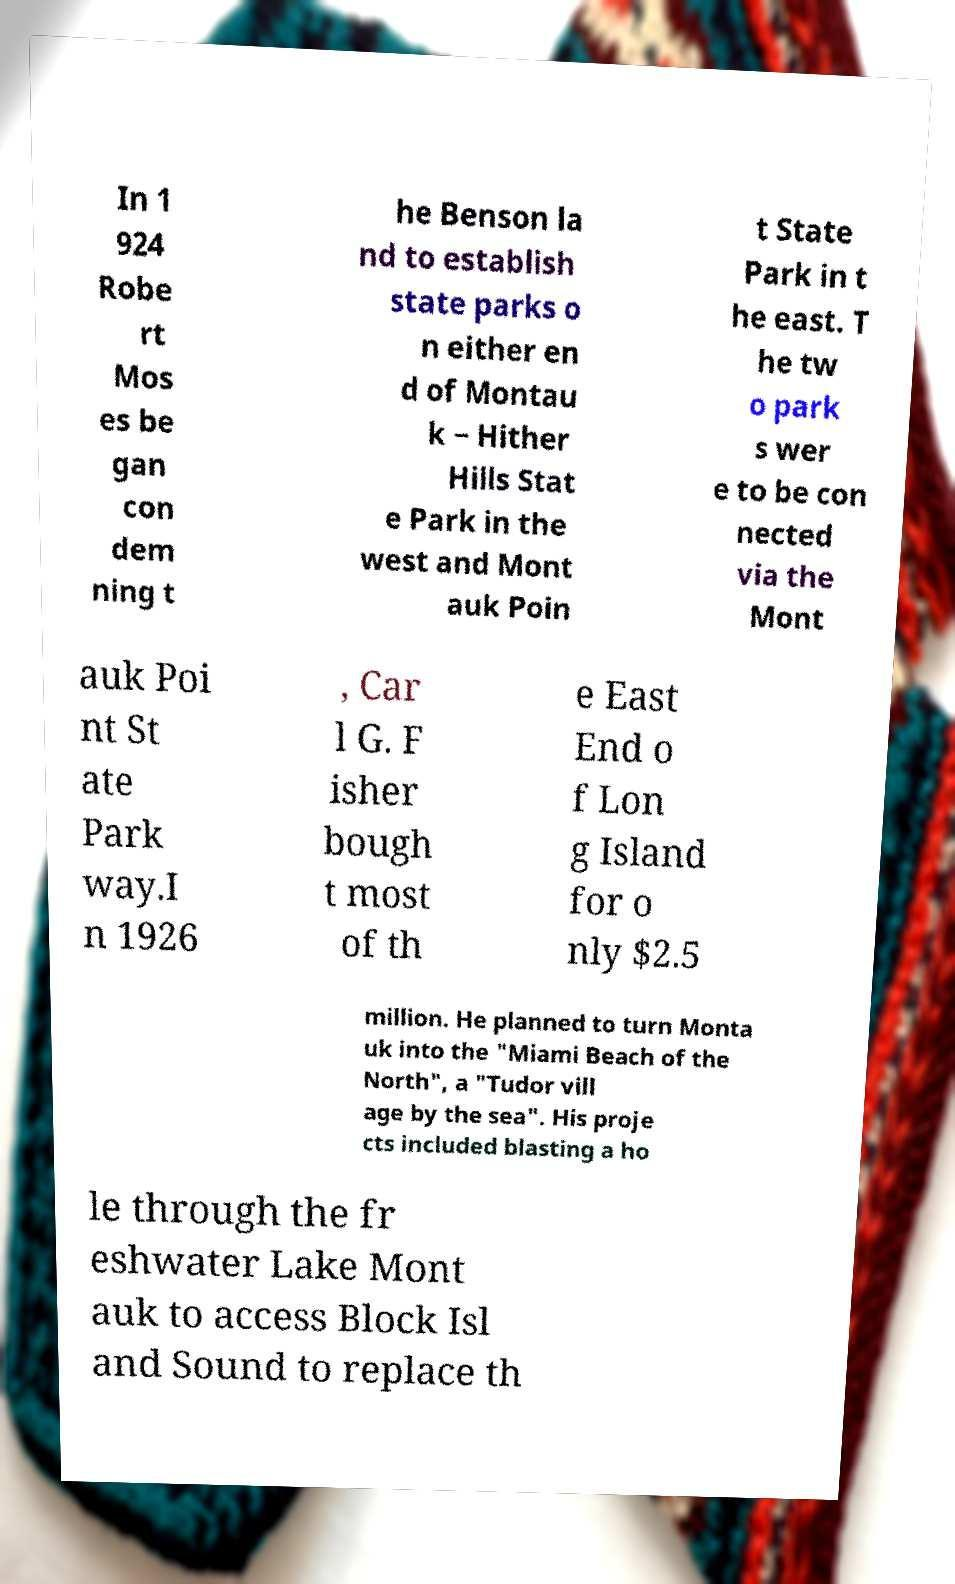For documentation purposes, I need the text within this image transcribed. Could you provide that? In 1 924 Robe rt Mos es be gan con dem ning t he Benson la nd to establish state parks o n either en d of Montau k − Hither Hills Stat e Park in the west and Mont auk Poin t State Park in t he east. T he tw o park s wer e to be con nected via the Mont auk Poi nt St ate Park way.I n 1926 , Car l G. F isher bough t most of th e East End o f Lon g Island for o nly $2.5 million. He planned to turn Monta uk into the "Miami Beach of the North", a "Tudor vill age by the sea". His proje cts included blasting a ho le through the fr eshwater Lake Mont auk to access Block Isl and Sound to replace th 